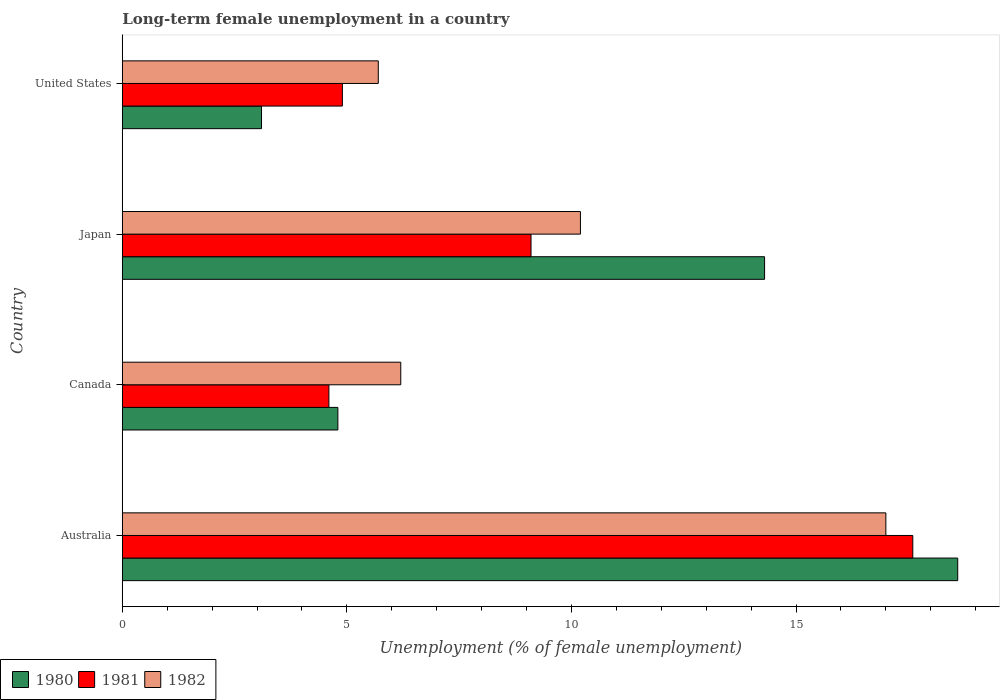How many different coloured bars are there?
Keep it short and to the point. 3. How many groups of bars are there?
Offer a terse response. 4. Are the number of bars per tick equal to the number of legend labels?
Provide a succinct answer. Yes. Are the number of bars on each tick of the Y-axis equal?
Give a very brief answer. Yes. In how many cases, is the number of bars for a given country not equal to the number of legend labels?
Your response must be concise. 0. What is the percentage of long-term unemployed female population in 1981 in Japan?
Offer a terse response. 9.1. Across all countries, what is the maximum percentage of long-term unemployed female population in 1981?
Offer a terse response. 17.6. Across all countries, what is the minimum percentage of long-term unemployed female population in 1982?
Keep it short and to the point. 5.7. In which country was the percentage of long-term unemployed female population in 1982 maximum?
Ensure brevity in your answer.  Australia. In which country was the percentage of long-term unemployed female population in 1980 minimum?
Your answer should be compact. United States. What is the total percentage of long-term unemployed female population in 1981 in the graph?
Offer a very short reply. 36.2. What is the difference between the percentage of long-term unemployed female population in 1980 in Australia and that in United States?
Provide a short and direct response. 15.5. What is the difference between the percentage of long-term unemployed female population in 1982 in Canada and the percentage of long-term unemployed female population in 1981 in Australia?
Your answer should be compact. -11.4. What is the average percentage of long-term unemployed female population in 1982 per country?
Give a very brief answer. 9.77. What is the difference between the percentage of long-term unemployed female population in 1982 and percentage of long-term unemployed female population in 1980 in Canada?
Provide a succinct answer. 1.4. What is the ratio of the percentage of long-term unemployed female population in 1981 in Australia to that in Canada?
Your response must be concise. 3.83. Is the percentage of long-term unemployed female population in 1981 in Australia less than that in United States?
Give a very brief answer. No. Is the difference between the percentage of long-term unemployed female population in 1982 in Canada and United States greater than the difference between the percentage of long-term unemployed female population in 1980 in Canada and United States?
Ensure brevity in your answer.  No. What is the difference between the highest and the second highest percentage of long-term unemployed female population in 1980?
Ensure brevity in your answer.  4.3. What is the difference between the highest and the lowest percentage of long-term unemployed female population in 1980?
Your answer should be compact. 15.5. In how many countries, is the percentage of long-term unemployed female population in 1982 greater than the average percentage of long-term unemployed female population in 1982 taken over all countries?
Your response must be concise. 2. Is the sum of the percentage of long-term unemployed female population in 1982 in Australia and Japan greater than the maximum percentage of long-term unemployed female population in 1981 across all countries?
Ensure brevity in your answer.  Yes. How many bars are there?
Your answer should be compact. 12. Are the values on the major ticks of X-axis written in scientific E-notation?
Ensure brevity in your answer.  No. Does the graph contain grids?
Provide a succinct answer. No. How many legend labels are there?
Keep it short and to the point. 3. What is the title of the graph?
Your response must be concise. Long-term female unemployment in a country. Does "1993" appear as one of the legend labels in the graph?
Provide a short and direct response. No. What is the label or title of the X-axis?
Keep it short and to the point. Unemployment (% of female unemployment). What is the Unemployment (% of female unemployment) in 1980 in Australia?
Provide a succinct answer. 18.6. What is the Unemployment (% of female unemployment) in 1981 in Australia?
Provide a short and direct response. 17.6. What is the Unemployment (% of female unemployment) of 1982 in Australia?
Your response must be concise. 17. What is the Unemployment (% of female unemployment) in 1980 in Canada?
Give a very brief answer. 4.8. What is the Unemployment (% of female unemployment) of 1981 in Canada?
Offer a terse response. 4.6. What is the Unemployment (% of female unemployment) of 1982 in Canada?
Ensure brevity in your answer.  6.2. What is the Unemployment (% of female unemployment) of 1980 in Japan?
Ensure brevity in your answer.  14.3. What is the Unemployment (% of female unemployment) of 1981 in Japan?
Keep it short and to the point. 9.1. What is the Unemployment (% of female unemployment) of 1982 in Japan?
Your answer should be very brief. 10.2. What is the Unemployment (% of female unemployment) in 1980 in United States?
Your answer should be very brief. 3.1. What is the Unemployment (% of female unemployment) of 1981 in United States?
Your answer should be very brief. 4.9. What is the Unemployment (% of female unemployment) in 1982 in United States?
Give a very brief answer. 5.7. Across all countries, what is the maximum Unemployment (% of female unemployment) of 1980?
Give a very brief answer. 18.6. Across all countries, what is the maximum Unemployment (% of female unemployment) in 1981?
Provide a short and direct response. 17.6. Across all countries, what is the maximum Unemployment (% of female unemployment) in 1982?
Your answer should be very brief. 17. Across all countries, what is the minimum Unemployment (% of female unemployment) of 1980?
Ensure brevity in your answer.  3.1. Across all countries, what is the minimum Unemployment (% of female unemployment) in 1981?
Your response must be concise. 4.6. Across all countries, what is the minimum Unemployment (% of female unemployment) of 1982?
Ensure brevity in your answer.  5.7. What is the total Unemployment (% of female unemployment) in 1980 in the graph?
Your answer should be compact. 40.8. What is the total Unemployment (% of female unemployment) in 1981 in the graph?
Keep it short and to the point. 36.2. What is the total Unemployment (% of female unemployment) in 1982 in the graph?
Provide a succinct answer. 39.1. What is the difference between the Unemployment (% of female unemployment) in 1980 in Australia and that in Canada?
Provide a succinct answer. 13.8. What is the difference between the Unemployment (% of female unemployment) of 1981 in Australia and that in Canada?
Keep it short and to the point. 13. What is the difference between the Unemployment (% of female unemployment) in 1982 in Australia and that in Canada?
Offer a terse response. 10.8. What is the difference between the Unemployment (% of female unemployment) of 1980 in Australia and that in Japan?
Your answer should be compact. 4.3. What is the difference between the Unemployment (% of female unemployment) of 1980 in Australia and that in United States?
Keep it short and to the point. 15.5. What is the difference between the Unemployment (% of female unemployment) in 1981 in Australia and that in United States?
Your answer should be compact. 12.7. What is the difference between the Unemployment (% of female unemployment) in 1981 in Canada and that in Japan?
Offer a terse response. -4.5. What is the difference between the Unemployment (% of female unemployment) in 1982 in Canada and that in Japan?
Give a very brief answer. -4. What is the difference between the Unemployment (% of female unemployment) of 1980 in Canada and that in United States?
Offer a very short reply. 1.7. What is the difference between the Unemployment (% of female unemployment) in 1982 in Canada and that in United States?
Offer a terse response. 0.5. What is the difference between the Unemployment (% of female unemployment) of 1981 in Japan and that in United States?
Offer a very short reply. 4.2. What is the difference between the Unemployment (% of female unemployment) in 1982 in Japan and that in United States?
Give a very brief answer. 4.5. What is the difference between the Unemployment (% of female unemployment) of 1980 in Australia and the Unemployment (% of female unemployment) of 1981 in Canada?
Provide a short and direct response. 14. What is the difference between the Unemployment (% of female unemployment) in 1980 in Australia and the Unemployment (% of female unemployment) in 1981 in Japan?
Your response must be concise. 9.5. What is the difference between the Unemployment (% of female unemployment) of 1980 in Australia and the Unemployment (% of female unemployment) of 1982 in Japan?
Offer a very short reply. 8.4. What is the difference between the Unemployment (% of female unemployment) in 1981 in Australia and the Unemployment (% of female unemployment) in 1982 in United States?
Your answer should be very brief. 11.9. What is the difference between the Unemployment (% of female unemployment) in 1981 in Canada and the Unemployment (% of female unemployment) in 1982 in Japan?
Offer a very short reply. -5.6. What is the difference between the Unemployment (% of female unemployment) in 1980 in Canada and the Unemployment (% of female unemployment) in 1981 in United States?
Your answer should be very brief. -0.1. What is the difference between the Unemployment (% of female unemployment) of 1980 in Japan and the Unemployment (% of female unemployment) of 1982 in United States?
Your answer should be compact. 8.6. What is the difference between the Unemployment (% of female unemployment) in 1981 in Japan and the Unemployment (% of female unemployment) in 1982 in United States?
Keep it short and to the point. 3.4. What is the average Unemployment (% of female unemployment) of 1980 per country?
Provide a short and direct response. 10.2. What is the average Unemployment (% of female unemployment) in 1981 per country?
Your answer should be very brief. 9.05. What is the average Unemployment (% of female unemployment) of 1982 per country?
Provide a succinct answer. 9.78. What is the difference between the Unemployment (% of female unemployment) in 1980 and Unemployment (% of female unemployment) in 1981 in Australia?
Ensure brevity in your answer.  1. What is the difference between the Unemployment (% of female unemployment) in 1980 and Unemployment (% of female unemployment) in 1981 in Canada?
Provide a short and direct response. 0.2. What is the difference between the Unemployment (% of female unemployment) in 1980 and Unemployment (% of female unemployment) in 1982 in Canada?
Provide a short and direct response. -1.4. What is the difference between the Unemployment (% of female unemployment) in 1980 and Unemployment (% of female unemployment) in 1981 in Japan?
Your answer should be very brief. 5.2. What is the difference between the Unemployment (% of female unemployment) in 1980 and Unemployment (% of female unemployment) in 1982 in Japan?
Ensure brevity in your answer.  4.1. What is the difference between the Unemployment (% of female unemployment) in 1980 and Unemployment (% of female unemployment) in 1981 in United States?
Your answer should be compact. -1.8. What is the difference between the Unemployment (% of female unemployment) in 1980 and Unemployment (% of female unemployment) in 1982 in United States?
Keep it short and to the point. -2.6. What is the difference between the Unemployment (% of female unemployment) of 1981 and Unemployment (% of female unemployment) of 1982 in United States?
Keep it short and to the point. -0.8. What is the ratio of the Unemployment (% of female unemployment) of 1980 in Australia to that in Canada?
Make the answer very short. 3.88. What is the ratio of the Unemployment (% of female unemployment) of 1981 in Australia to that in Canada?
Keep it short and to the point. 3.83. What is the ratio of the Unemployment (% of female unemployment) in 1982 in Australia to that in Canada?
Make the answer very short. 2.74. What is the ratio of the Unemployment (% of female unemployment) in 1980 in Australia to that in Japan?
Give a very brief answer. 1.3. What is the ratio of the Unemployment (% of female unemployment) in 1981 in Australia to that in Japan?
Your answer should be very brief. 1.93. What is the ratio of the Unemployment (% of female unemployment) in 1981 in Australia to that in United States?
Make the answer very short. 3.59. What is the ratio of the Unemployment (% of female unemployment) in 1982 in Australia to that in United States?
Provide a succinct answer. 2.98. What is the ratio of the Unemployment (% of female unemployment) of 1980 in Canada to that in Japan?
Your answer should be very brief. 0.34. What is the ratio of the Unemployment (% of female unemployment) in 1981 in Canada to that in Japan?
Your answer should be compact. 0.51. What is the ratio of the Unemployment (% of female unemployment) of 1982 in Canada to that in Japan?
Provide a short and direct response. 0.61. What is the ratio of the Unemployment (% of female unemployment) of 1980 in Canada to that in United States?
Provide a succinct answer. 1.55. What is the ratio of the Unemployment (% of female unemployment) of 1981 in Canada to that in United States?
Ensure brevity in your answer.  0.94. What is the ratio of the Unemployment (% of female unemployment) in 1982 in Canada to that in United States?
Offer a terse response. 1.09. What is the ratio of the Unemployment (% of female unemployment) of 1980 in Japan to that in United States?
Keep it short and to the point. 4.61. What is the ratio of the Unemployment (% of female unemployment) in 1981 in Japan to that in United States?
Provide a succinct answer. 1.86. What is the ratio of the Unemployment (% of female unemployment) in 1982 in Japan to that in United States?
Ensure brevity in your answer.  1.79. What is the difference between the highest and the lowest Unemployment (% of female unemployment) in 1982?
Keep it short and to the point. 11.3. 